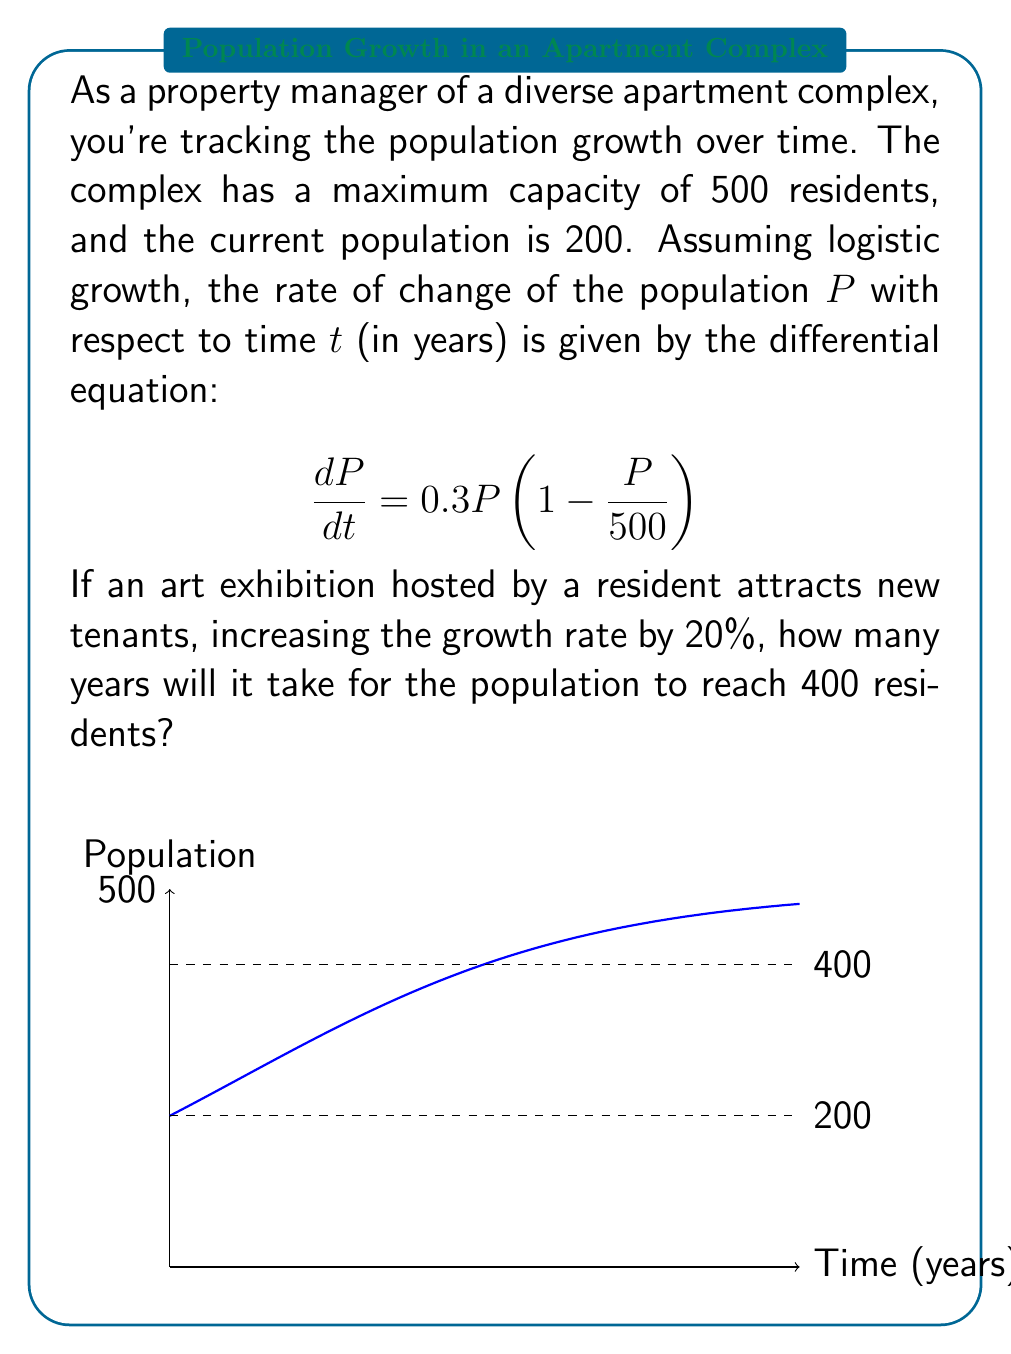Can you solve this math problem? Let's approach this step-by-step:

1) First, we need to modify the differential equation to account for the 20% increase in growth rate:

   $$\frac{dP}{dt} = 0.3 \cdot 1.2 \cdot P\left(1 - \frac{P}{500}\right) = 0.36P\left(1 - \frac{P}{500}\right)$$

2) This is a logistic differential equation of the form:

   $$\frac{dP}{dt} = rP\left(1 - \frac{P}{K}\right)$$

   where $r = 0.36$ and $K = 500$.

3) The solution to this equation is:

   $$P(t) = \frac{K}{1 + Ce^{-rt}}$$

   where $C$ is a constant determined by the initial conditions.

4) At $t = 0$, $P(0) = 200$. Let's use this to find $C$:

   $$200 = \frac{500}{1 + C}$$
   $$C = \frac{500}{200} - 1 = 1.5$$

5) So our specific solution is:

   $$P(t) = \frac{500}{1 + 1.5e^{-0.36t}}$$

6) We want to find $t$ when $P(t) = 400$. Let's substitute this:

   $$400 = \frac{500}{1 + 1.5e^{-0.36t}}$$

7) Solving for $t$:

   $$1 + 1.5e^{-0.36t} = \frac{500}{400} = 1.25$$
   $$1.5e^{-0.36t} = 0.25$$
   $$e^{-0.36t} = \frac{1}{6}$$
   $$-0.36t = \ln(\frac{1}{6})$$
   $$t = -\frac{\ln(\frac{1}{6})}{0.36} \approx 4.95$$

Therefore, it will take approximately 4.95 years for the population to reach 400 residents.
Answer: 4.95 years 